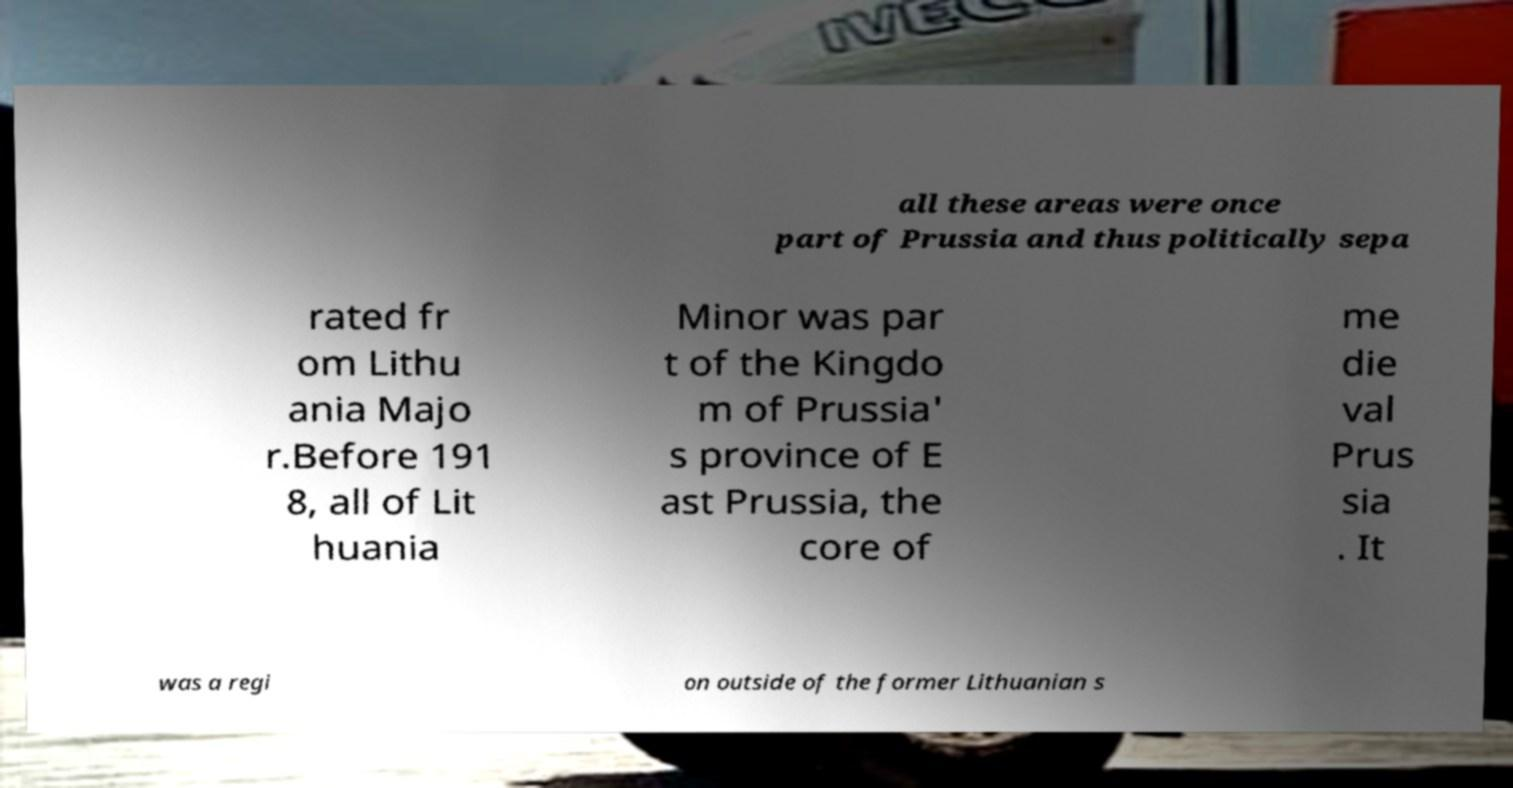There's text embedded in this image that I need extracted. Can you transcribe it verbatim? all these areas were once part of Prussia and thus politically sepa rated fr om Lithu ania Majo r.Before 191 8, all of Lit huania Minor was par t of the Kingdo m of Prussia' s province of E ast Prussia, the core of me die val Prus sia . It was a regi on outside of the former Lithuanian s 